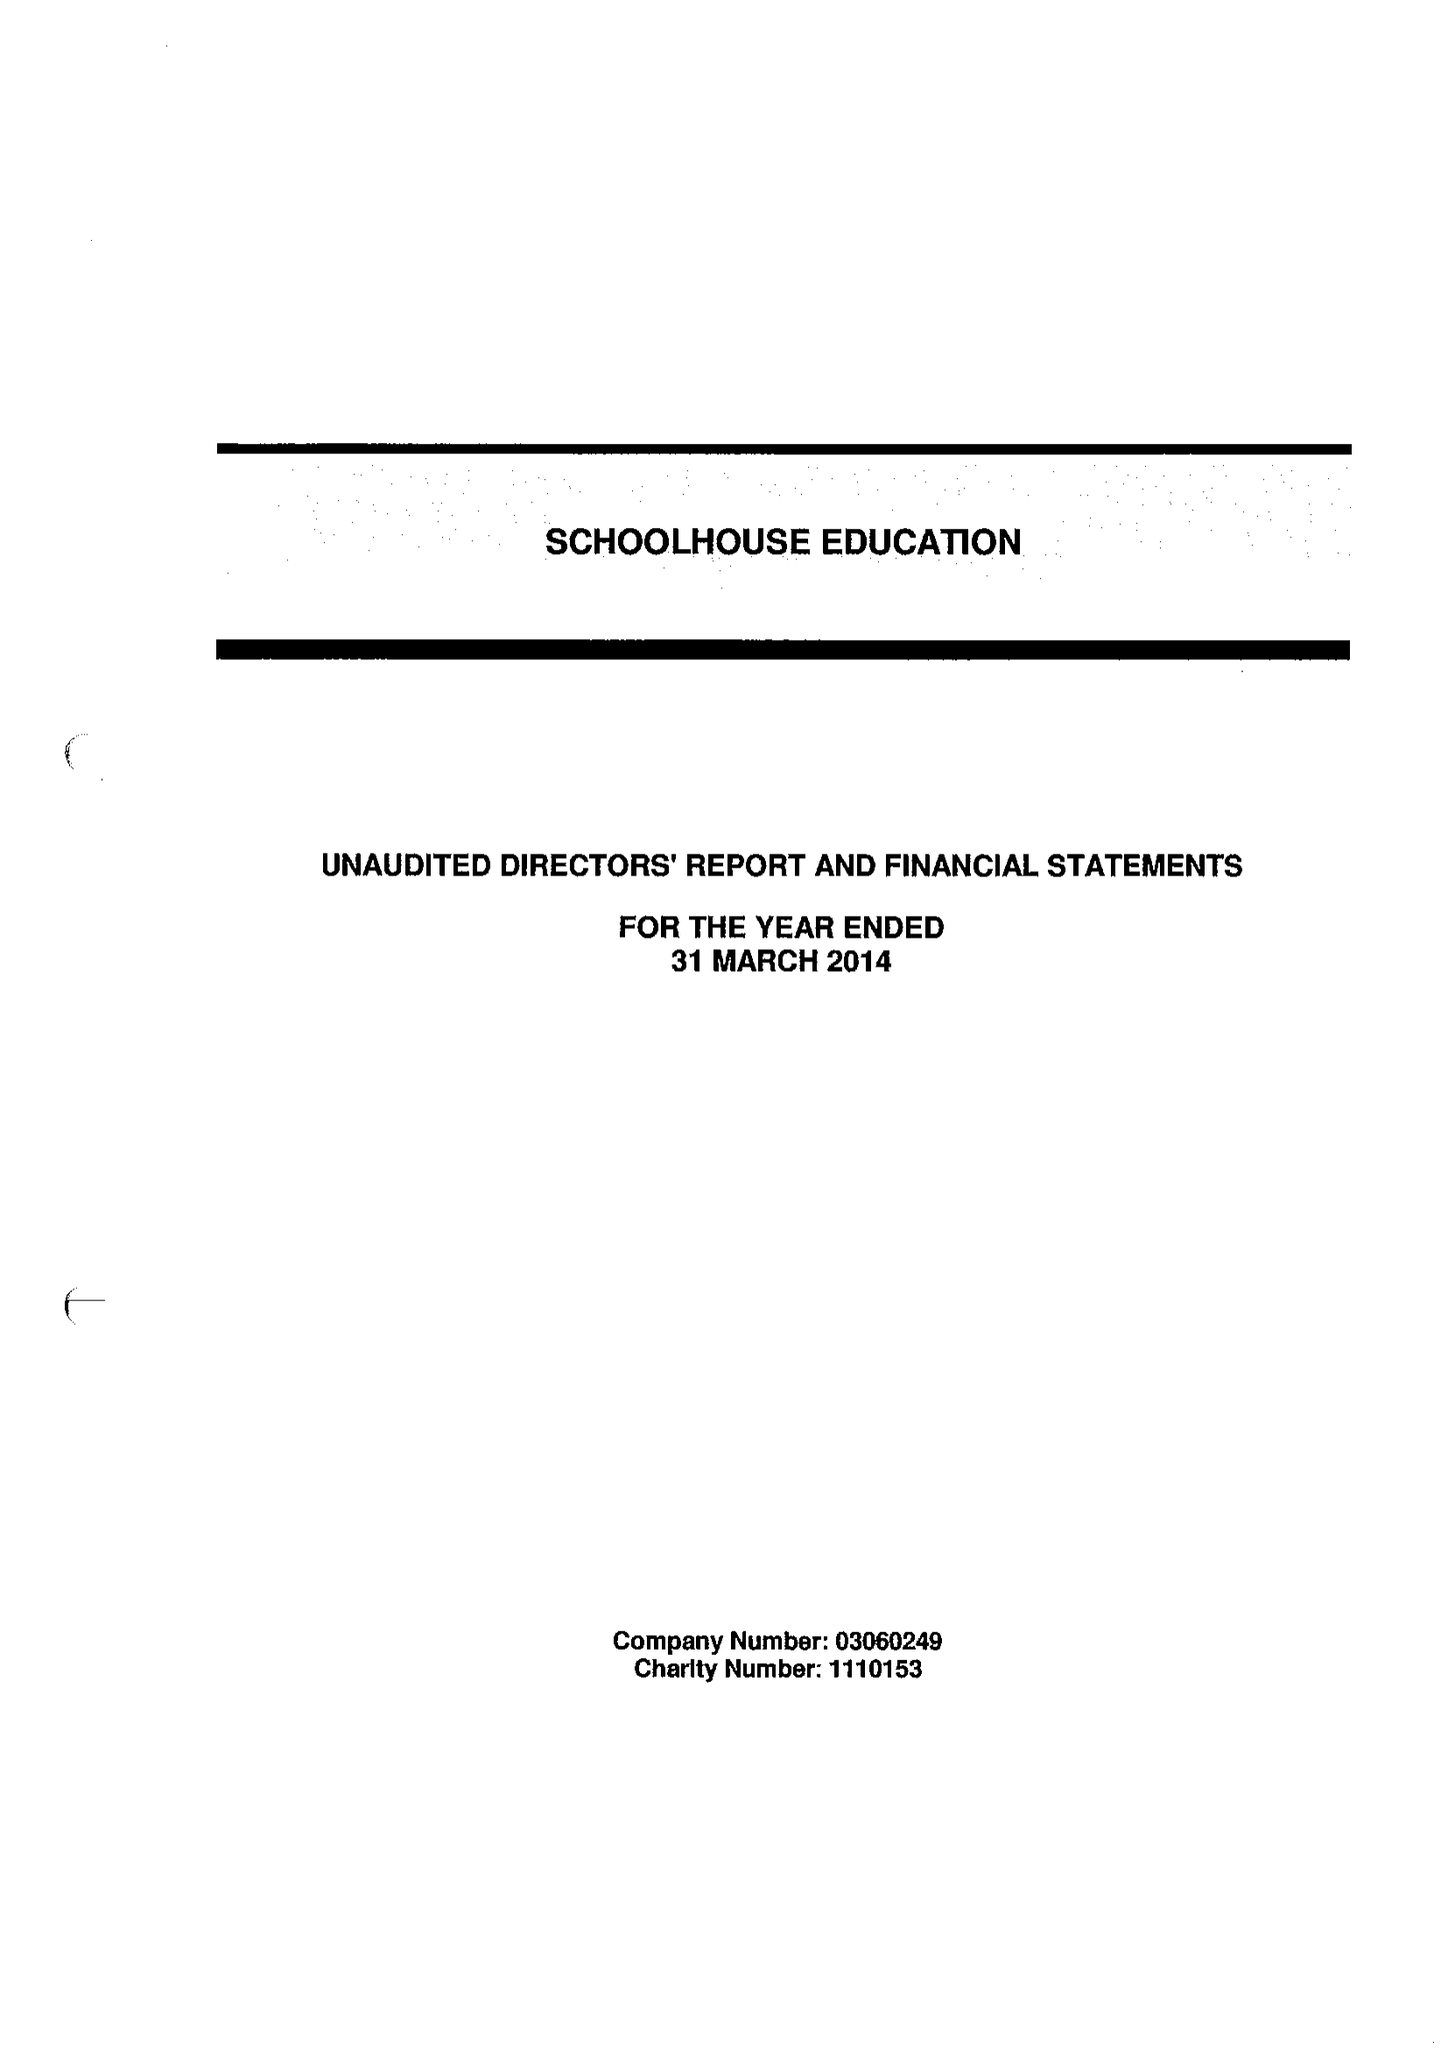What is the value for the charity_number?
Answer the question using a single word or phrase. 1110153 